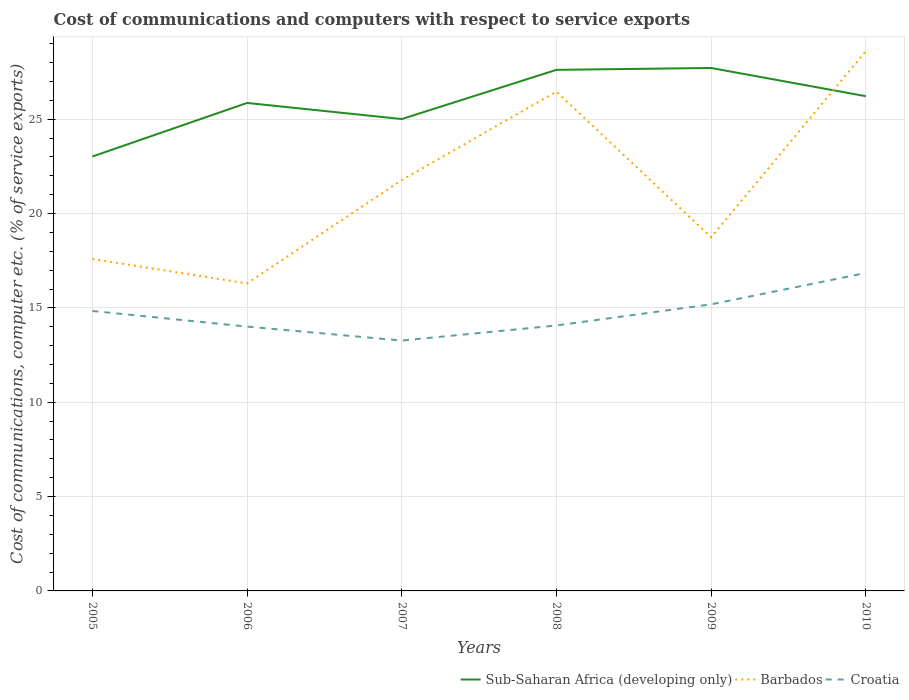Is the number of lines equal to the number of legend labels?
Provide a short and direct response. Yes. Across all years, what is the maximum cost of communications and computers in Sub-Saharan Africa (developing only)?
Make the answer very short. 23.02. What is the total cost of communications and computers in Croatia in the graph?
Your response must be concise. 0.83. What is the difference between the highest and the second highest cost of communications and computers in Barbados?
Your answer should be compact. 12.31. What is the difference between the highest and the lowest cost of communications and computers in Barbados?
Provide a short and direct response. 3. Is the cost of communications and computers in Croatia strictly greater than the cost of communications and computers in Sub-Saharan Africa (developing only) over the years?
Your answer should be compact. Yes. What is the difference between two consecutive major ticks on the Y-axis?
Ensure brevity in your answer.  5. Does the graph contain grids?
Make the answer very short. Yes. Where does the legend appear in the graph?
Make the answer very short. Bottom right. How many legend labels are there?
Give a very brief answer. 3. How are the legend labels stacked?
Your response must be concise. Horizontal. What is the title of the graph?
Offer a very short reply. Cost of communications and computers with respect to service exports. Does "San Marino" appear as one of the legend labels in the graph?
Offer a very short reply. No. What is the label or title of the Y-axis?
Keep it short and to the point. Cost of communications, computer etc. (% of service exports). What is the Cost of communications, computer etc. (% of service exports) of Sub-Saharan Africa (developing only) in 2005?
Ensure brevity in your answer.  23.02. What is the Cost of communications, computer etc. (% of service exports) of Barbados in 2005?
Ensure brevity in your answer.  17.59. What is the Cost of communications, computer etc. (% of service exports) of Croatia in 2005?
Your answer should be very brief. 14.84. What is the Cost of communications, computer etc. (% of service exports) of Sub-Saharan Africa (developing only) in 2006?
Give a very brief answer. 25.86. What is the Cost of communications, computer etc. (% of service exports) of Barbados in 2006?
Your response must be concise. 16.3. What is the Cost of communications, computer etc. (% of service exports) of Croatia in 2006?
Your answer should be compact. 14.01. What is the Cost of communications, computer etc. (% of service exports) in Sub-Saharan Africa (developing only) in 2007?
Your response must be concise. 25.01. What is the Cost of communications, computer etc. (% of service exports) of Barbados in 2007?
Make the answer very short. 21.77. What is the Cost of communications, computer etc. (% of service exports) in Croatia in 2007?
Your response must be concise. 13.27. What is the Cost of communications, computer etc. (% of service exports) in Sub-Saharan Africa (developing only) in 2008?
Your answer should be compact. 27.62. What is the Cost of communications, computer etc. (% of service exports) in Barbados in 2008?
Make the answer very short. 26.46. What is the Cost of communications, computer etc. (% of service exports) of Croatia in 2008?
Your answer should be very brief. 14.07. What is the Cost of communications, computer etc. (% of service exports) in Sub-Saharan Africa (developing only) in 2009?
Offer a very short reply. 27.71. What is the Cost of communications, computer etc. (% of service exports) of Barbados in 2009?
Provide a short and direct response. 18.74. What is the Cost of communications, computer etc. (% of service exports) of Croatia in 2009?
Offer a terse response. 15.19. What is the Cost of communications, computer etc. (% of service exports) of Sub-Saharan Africa (developing only) in 2010?
Your answer should be very brief. 26.22. What is the Cost of communications, computer etc. (% of service exports) of Barbados in 2010?
Offer a terse response. 28.61. What is the Cost of communications, computer etc. (% of service exports) of Croatia in 2010?
Provide a short and direct response. 16.85. Across all years, what is the maximum Cost of communications, computer etc. (% of service exports) of Sub-Saharan Africa (developing only)?
Offer a terse response. 27.71. Across all years, what is the maximum Cost of communications, computer etc. (% of service exports) of Barbados?
Provide a short and direct response. 28.61. Across all years, what is the maximum Cost of communications, computer etc. (% of service exports) of Croatia?
Offer a terse response. 16.85. Across all years, what is the minimum Cost of communications, computer etc. (% of service exports) of Sub-Saharan Africa (developing only)?
Make the answer very short. 23.02. Across all years, what is the minimum Cost of communications, computer etc. (% of service exports) in Barbados?
Give a very brief answer. 16.3. Across all years, what is the minimum Cost of communications, computer etc. (% of service exports) of Croatia?
Your response must be concise. 13.27. What is the total Cost of communications, computer etc. (% of service exports) in Sub-Saharan Africa (developing only) in the graph?
Make the answer very short. 155.44. What is the total Cost of communications, computer etc. (% of service exports) of Barbados in the graph?
Your response must be concise. 129.48. What is the total Cost of communications, computer etc. (% of service exports) of Croatia in the graph?
Ensure brevity in your answer.  88.22. What is the difference between the Cost of communications, computer etc. (% of service exports) of Sub-Saharan Africa (developing only) in 2005 and that in 2006?
Ensure brevity in your answer.  -2.84. What is the difference between the Cost of communications, computer etc. (% of service exports) in Barbados in 2005 and that in 2006?
Make the answer very short. 1.29. What is the difference between the Cost of communications, computer etc. (% of service exports) of Croatia in 2005 and that in 2006?
Make the answer very short. 0.83. What is the difference between the Cost of communications, computer etc. (% of service exports) of Sub-Saharan Africa (developing only) in 2005 and that in 2007?
Offer a terse response. -1.99. What is the difference between the Cost of communications, computer etc. (% of service exports) in Barbados in 2005 and that in 2007?
Ensure brevity in your answer.  -4.18. What is the difference between the Cost of communications, computer etc. (% of service exports) of Croatia in 2005 and that in 2007?
Keep it short and to the point. 1.57. What is the difference between the Cost of communications, computer etc. (% of service exports) of Sub-Saharan Africa (developing only) in 2005 and that in 2008?
Offer a very short reply. -4.59. What is the difference between the Cost of communications, computer etc. (% of service exports) in Barbados in 2005 and that in 2008?
Keep it short and to the point. -8.87. What is the difference between the Cost of communications, computer etc. (% of service exports) in Croatia in 2005 and that in 2008?
Your response must be concise. 0.77. What is the difference between the Cost of communications, computer etc. (% of service exports) in Sub-Saharan Africa (developing only) in 2005 and that in 2009?
Your response must be concise. -4.69. What is the difference between the Cost of communications, computer etc. (% of service exports) of Barbados in 2005 and that in 2009?
Offer a very short reply. -1.15. What is the difference between the Cost of communications, computer etc. (% of service exports) of Croatia in 2005 and that in 2009?
Your answer should be very brief. -0.35. What is the difference between the Cost of communications, computer etc. (% of service exports) in Sub-Saharan Africa (developing only) in 2005 and that in 2010?
Offer a very short reply. -3.2. What is the difference between the Cost of communications, computer etc. (% of service exports) in Barbados in 2005 and that in 2010?
Keep it short and to the point. -11.02. What is the difference between the Cost of communications, computer etc. (% of service exports) of Croatia in 2005 and that in 2010?
Offer a very short reply. -2.02. What is the difference between the Cost of communications, computer etc. (% of service exports) in Sub-Saharan Africa (developing only) in 2006 and that in 2007?
Your response must be concise. 0.85. What is the difference between the Cost of communications, computer etc. (% of service exports) of Barbados in 2006 and that in 2007?
Offer a very short reply. -5.48. What is the difference between the Cost of communications, computer etc. (% of service exports) in Croatia in 2006 and that in 2007?
Ensure brevity in your answer.  0.74. What is the difference between the Cost of communications, computer etc. (% of service exports) of Sub-Saharan Africa (developing only) in 2006 and that in 2008?
Ensure brevity in your answer.  -1.75. What is the difference between the Cost of communications, computer etc. (% of service exports) of Barbados in 2006 and that in 2008?
Ensure brevity in your answer.  -10.16. What is the difference between the Cost of communications, computer etc. (% of service exports) of Croatia in 2006 and that in 2008?
Offer a terse response. -0.06. What is the difference between the Cost of communications, computer etc. (% of service exports) of Sub-Saharan Africa (developing only) in 2006 and that in 2009?
Your response must be concise. -1.85. What is the difference between the Cost of communications, computer etc. (% of service exports) in Barbados in 2006 and that in 2009?
Provide a succinct answer. -2.44. What is the difference between the Cost of communications, computer etc. (% of service exports) in Croatia in 2006 and that in 2009?
Offer a terse response. -1.18. What is the difference between the Cost of communications, computer etc. (% of service exports) in Sub-Saharan Africa (developing only) in 2006 and that in 2010?
Make the answer very short. -0.36. What is the difference between the Cost of communications, computer etc. (% of service exports) of Barbados in 2006 and that in 2010?
Provide a short and direct response. -12.31. What is the difference between the Cost of communications, computer etc. (% of service exports) in Croatia in 2006 and that in 2010?
Make the answer very short. -2.84. What is the difference between the Cost of communications, computer etc. (% of service exports) in Sub-Saharan Africa (developing only) in 2007 and that in 2008?
Provide a succinct answer. -2.61. What is the difference between the Cost of communications, computer etc. (% of service exports) in Barbados in 2007 and that in 2008?
Give a very brief answer. -4.69. What is the difference between the Cost of communications, computer etc. (% of service exports) in Croatia in 2007 and that in 2008?
Your answer should be very brief. -0.8. What is the difference between the Cost of communications, computer etc. (% of service exports) of Sub-Saharan Africa (developing only) in 2007 and that in 2009?
Offer a very short reply. -2.71. What is the difference between the Cost of communications, computer etc. (% of service exports) in Barbados in 2007 and that in 2009?
Your answer should be compact. 3.03. What is the difference between the Cost of communications, computer etc. (% of service exports) of Croatia in 2007 and that in 2009?
Your answer should be very brief. -1.92. What is the difference between the Cost of communications, computer etc. (% of service exports) in Sub-Saharan Africa (developing only) in 2007 and that in 2010?
Keep it short and to the point. -1.21. What is the difference between the Cost of communications, computer etc. (% of service exports) in Barbados in 2007 and that in 2010?
Provide a succinct answer. -6.84. What is the difference between the Cost of communications, computer etc. (% of service exports) of Croatia in 2007 and that in 2010?
Offer a terse response. -3.58. What is the difference between the Cost of communications, computer etc. (% of service exports) of Sub-Saharan Africa (developing only) in 2008 and that in 2009?
Provide a short and direct response. -0.1. What is the difference between the Cost of communications, computer etc. (% of service exports) in Barbados in 2008 and that in 2009?
Your response must be concise. 7.72. What is the difference between the Cost of communications, computer etc. (% of service exports) of Croatia in 2008 and that in 2009?
Give a very brief answer. -1.12. What is the difference between the Cost of communications, computer etc. (% of service exports) of Sub-Saharan Africa (developing only) in 2008 and that in 2010?
Provide a short and direct response. 1.4. What is the difference between the Cost of communications, computer etc. (% of service exports) of Barbados in 2008 and that in 2010?
Make the answer very short. -2.15. What is the difference between the Cost of communications, computer etc. (% of service exports) in Croatia in 2008 and that in 2010?
Give a very brief answer. -2.78. What is the difference between the Cost of communications, computer etc. (% of service exports) in Sub-Saharan Africa (developing only) in 2009 and that in 2010?
Give a very brief answer. 1.5. What is the difference between the Cost of communications, computer etc. (% of service exports) of Barbados in 2009 and that in 2010?
Your response must be concise. -9.87. What is the difference between the Cost of communications, computer etc. (% of service exports) in Croatia in 2009 and that in 2010?
Ensure brevity in your answer.  -1.66. What is the difference between the Cost of communications, computer etc. (% of service exports) in Sub-Saharan Africa (developing only) in 2005 and the Cost of communications, computer etc. (% of service exports) in Barbados in 2006?
Provide a short and direct response. 6.73. What is the difference between the Cost of communications, computer etc. (% of service exports) of Sub-Saharan Africa (developing only) in 2005 and the Cost of communications, computer etc. (% of service exports) of Croatia in 2006?
Provide a short and direct response. 9.01. What is the difference between the Cost of communications, computer etc. (% of service exports) of Barbados in 2005 and the Cost of communications, computer etc. (% of service exports) of Croatia in 2006?
Your answer should be compact. 3.58. What is the difference between the Cost of communications, computer etc. (% of service exports) of Sub-Saharan Africa (developing only) in 2005 and the Cost of communications, computer etc. (% of service exports) of Barbados in 2007?
Give a very brief answer. 1.25. What is the difference between the Cost of communications, computer etc. (% of service exports) in Sub-Saharan Africa (developing only) in 2005 and the Cost of communications, computer etc. (% of service exports) in Croatia in 2007?
Provide a short and direct response. 9.75. What is the difference between the Cost of communications, computer etc. (% of service exports) in Barbados in 2005 and the Cost of communications, computer etc. (% of service exports) in Croatia in 2007?
Give a very brief answer. 4.32. What is the difference between the Cost of communications, computer etc. (% of service exports) of Sub-Saharan Africa (developing only) in 2005 and the Cost of communications, computer etc. (% of service exports) of Barbados in 2008?
Offer a very short reply. -3.44. What is the difference between the Cost of communications, computer etc. (% of service exports) in Sub-Saharan Africa (developing only) in 2005 and the Cost of communications, computer etc. (% of service exports) in Croatia in 2008?
Ensure brevity in your answer.  8.96. What is the difference between the Cost of communications, computer etc. (% of service exports) in Barbados in 2005 and the Cost of communications, computer etc. (% of service exports) in Croatia in 2008?
Keep it short and to the point. 3.52. What is the difference between the Cost of communications, computer etc. (% of service exports) in Sub-Saharan Africa (developing only) in 2005 and the Cost of communications, computer etc. (% of service exports) in Barbados in 2009?
Make the answer very short. 4.28. What is the difference between the Cost of communications, computer etc. (% of service exports) in Sub-Saharan Africa (developing only) in 2005 and the Cost of communications, computer etc. (% of service exports) in Croatia in 2009?
Your answer should be compact. 7.83. What is the difference between the Cost of communications, computer etc. (% of service exports) of Barbados in 2005 and the Cost of communications, computer etc. (% of service exports) of Croatia in 2009?
Your response must be concise. 2.4. What is the difference between the Cost of communications, computer etc. (% of service exports) in Sub-Saharan Africa (developing only) in 2005 and the Cost of communications, computer etc. (% of service exports) in Barbados in 2010?
Ensure brevity in your answer.  -5.59. What is the difference between the Cost of communications, computer etc. (% of service exports) of Sub-Saharan Africa (developing only) in 2005 and the Cost of communications, computer etc. (% of service exports) of Croatia in 2010?
Provide a succinct answer. 6.17. What is the difference between the Cost of communications, computer etc. (% of service exports) of Barbados in 2005 and the Cost of communications, computer etc. (% of service exports) of Croatia in 2010?
Make the answer very short. 0.74. What is the difference between the Cost of communications, computer etc. (% of service exports) of Sub-Saharan Africa (developing only) in 2006 and the Cost of communications, computer etc. (% of service exports) of Barbados in 2007?
Provide a succinct answer. 4.09. What is the difference between the Cost of communications, computer etc. (% of service exports) of Sub-Saharan Africa (developing only) in 2006 and the Cost of communications, computer etc. (% of service exports) of Croatia in 2007?
Keep it short and to the point. 12.59. What is the difference between the Cost of communications, computer etc. (% of service exports) in Barbados in 2006 and the Cost of communications, computer etc. (% of service exports) in Croatia in 2007?
Provide a succinct answer. 3.03. What is the difference between the Cost of communications, computer etc. (% of service exports) in Sub-Saharan Africa (developing only) in 2006 and the Cost of communications, computer etc. (% of service exports) in Barbados in 2008?
Provide a short and direct response. -0.6. What is the difference between the Cost of communications, computer etc. (% of service exports) of Sub-Saharan Africa (developing only) in 2006 and the Cost of communications, computer etc. (% of service exports) of Croatia in 2008?
Your answer should be very brief. 11.79. What is the difference between the Cost of communications, computer etc. (% of service exports) of Barbados in 2006 and the Cost of communications, computer etc. (% of service exports) of Croatia in 2008?
Provide a short and direct response. 2.23. What is the difference between the Cost of communications, computer etc. (% of service exports) in Sub-Saharan Africa (developing only) in 2006 and the Cost of communications, computer etc. (% of service exports) in Barbados in 2009?
Keep it short and to the point. 7.12. What is the difference between the Cost of communications, computer etc. (% of service exports) in Sub-Saharan Africa (developing only) in 2006 and the Cost of communications, computer etc. (% of service exports) in Croatia in 2009?
Your answer should be very brief. 10.67. What is the difference between the Cost of communications, computer etc. (% of service exports) in Barbados in 2006 and the Cost of communications, computer etc. (% of service exports) in Croatia in 2009?
Offer a very short reply. 1.11. What is the difference between the Cost of communications, computer etc. (% of service exports) of Sub-Saharan Africa (developing only) in 2006 and the Cost of communications, computer etc. (% of service exports) of Barbados in 2010?
Offer a terse response. -2.75. What is the difference between the Cost of communications, computer etc. (% of service exports) of Sub-Saharan Africa (developing only) in 2006 and the Cost of communications, computer etc. (% of service exports) of Croatia in 2010?
Offer a terse response. 9.01. What is the difference between the Cost of communications, computer etc. (% of service exports) of Barbados in 2006 and the Cost of communications, computer etc. (% of service exports) of Croatia in 2010?
Ensure brevity in your answer.  -0.55. What is the difference between the Cost of communications, computer etc. (% of service exports) in Sub-Saharan Africa (developing only) in 2007 and the Cost of communications, computer etc. (% of service exports) in Barbados in 2008?
Offer a terse response. -1.45. What is the difference between the Cost of communications, computer etc. (% of service exports) in Sub-Saharan Africa (developing only) in 2007 and the Cost of communications, computer etc. (% of service exports) in Croatia in 2008?
Offer a terse response. 10.94. What is the difference between the Cost of communications, computer etc. (% of service exports) of Barbados in 2007 and the Cost of communications, computer etc. (% of service exports) of Croatia in 2008?
Give a very brief answer. 7.71. What is the difference between the Cost of communications, computer etc. (% of service exports) in Sub-Saharan Africa (developing only) in 2007 and the Cost of communications, computer etc. (% of service exports) in Barbados in 2009?
Keep it short and to the point. 6.27. What is the difference between the Cost of communications, computer etc. (% of service exports) in Sub-Saharan Africa (developing only) in 2007 and the Cost of communications, computer etc. (% of service exports) in Croatia in 2009?
Provide a short and direct response. 9.82. What is the difference between the Cost of communications, computer etc. (% of service exports) of Barbados in 2007 and the Cost of communications, computer etc. (% of service exports) of Croatia in 2009?
Provide a short and direct response. 6.59. What is the difference between the Cost of communications, computer etc. (% of service exports) of Sub-Saharan Africa (developing only) in 2007 and the Cost of communications, computer etc. (% of service exports) of Barbados in 2010?
Keep it short and to the point. -3.6. What is the difference between the Cost of communications, computer etc. (% of service exports) of Sub-Saharan Africa (developing only) in 2007 and the Cost of communications, computer etc. (% of service exports) of Croatia in 2010?
Provide a succinct answer. 8.16. What is the difference between the Cost of communications, computer etc. (% of service exports) in Barbados in 2007 and the Cost of communications, computer etc. (% of service exports) in Croatia in 2010?
Offer a very short reply. 4.92. What is the difference between the Cost of communications, computer etc. (% of service exports) of Sub-Saharan Africa (developing only) in 2008 and the Cost of communications, computer etc. (% of service exports) of Barbados in 2009?
Keep it short and to the point. 8.88. What is the difference between the Cost of communications, computer etc. (% of service exports) in Sub-Saharan Africa (developing only) in 2008 and the Cost of communications, computer etc. (% of service exports) in Croatia in 2009?
Offer a terse response. 12.43. What is the difference between the Cost of communications, computer etc. (% of service exports) of Barbados in 2008 and the Cost of communications, computer etc. (% of service exports) of Croatia in 2009?
Your response must be concise. 11.27. What is the difference between the Cost of communications, computer etc. (% of service exports) of Sub-Saharan Africa (developing only) in 2008 and the Cost of communications, computer etc. (% of service exports) of Barbados in 2010?
Provide a succinct answer. -1. What is the difference between the Cost of communications, computer etc. (% of service exports) in Sub-Saharan Africa (developing only) in 2008 and the Cost of communications, computer etc. (% of service exports) in Croatia in 2010?
Your answer should be compact. 10.76. What is the difference between the Cost of communications, computer etc. (% of service exports) of Barbados in 2008 and the Cost of communications, computer etc. (% of service exports) of Croatia in 2010?
Your answer should be compact. 9.61. What is the difference between the Cost of communications, computer etc. (% of service exports) in Sub-Saharan Africa (developing only) in 2009 and the Cost of communications, computer etc. (% of service exports) in Barbados in 2010?
Your response must be concise. -0.9. What is the difference between the Cost of communications, computer etc. (% of service exports) of Sub-Saharan Africa (developing only) in 2009 and the Cost of communications, computer etc. (% of service exports) of Croatia in 2010?
Your answer should be compact. 10.86. What is the difference between the Cost of communications, computer etc. (% of service exports) in Barbados in 2009 and the Cost of communications, computer etc. (% of service exports) in Croatia in 2010?
Make the answer very short. 1.89. What is the average Cost of communications, computer etc. (% of service exports) of Sub-Saharan Africa (developing only) per year?
Your answer should be compact. 25.91. What is the average Cost of communications, computer etc. (% of service exports) of Barbados per year?
Offer a very short reply. 21.58. What is the average Cost of communications, computer etc. (% of service exports) in Croatia per year?
Keep it short and to the point. 14.7. In the year 2005, what is the difference between the Cost of communications, computer etc. (% of service exports) of Sub-Saharan Africa (developing only) and Cost of communications, computer etc. (% of service exports) of Barbados?
Ensure brevity in your answer.  5.43. In the year 2005, what is the difference between the Cost of communications, computer etc. (% of service exports) in Sub-Saharan Africa (developing only) and Cost of communications, computer etc. (% of service exports) in Croatia?
Your answer should be compact. 8.19. In the year 2005, what is the difference between the Cost of communications, computer etc. (% of service exports) of Barbados and Cost of communications, computer etc. (% of service exports) of Croatia?
Offer a terse response. 2.75. In the year 2006, what is the difference between the Cost of communications, computer etc. (% of service exports) of Sub-Saharan Africa (developing only) and Cost of communications, computer etc. (% of service exports) of Barbados?
Provide a succinct answer. 9.56. In the year 2006, what is the difference between the Cost of communications, computer etc. (% of service exports) of Sub-Saharan Africa (developing only) and Cost of communications, computer etc. (% of service exports) of Croatia?
Offer a very short reply. 11.85. In the year 2006, what is the difference between the Cost of communications, computer etc. (% of service exports) in Barbados and Cost of communications, computer etc. (% of service exports) in Croatia?
Give a very brief answer. 2.29. In the year 2007, what is the difference between the Cost of communications, computer etc. (% of service exports) in Sub-Saharan Africa (developing only) and Cost of communications, computer etc. (% of service exports) in Barbados?
Keep it short and to the point. 3.23. In the year 2007, what is the difference between the Cost of communications, computer etc. (% of service exports) of Sub-Saharan Africa (developing only) and Cost of communications, computer etc. (% of service exports) of Croatia?
Offer a terse response. 11.74. In the year 2007, what is the difference between the Cost of communications, computer etc. (% of service exports) in Barbados and Cost of communications, computer etc. (% of service exports) in Croatia?
Give a very brief answer. 8.51. In the year 2008, what is the difference between the Cost of communications, computer etc. (% of service exports) in Sub-Saharan Africa (developing only) and Cost of communications, computer etc. (% of service exports) in Barbados?
Your response must be concise. 1.15. In the year 2008, what is the difference between the Cost of communications, computer etc. (% of service exports) in Sub-Saharan Africa (developing only) and Cost of communications, computer etc. (% of service exports) in Croatia?
Offer a terse response. 13.55. In the year 2008, what is the difference between the Cost of communications, computer etc. (% of service exports) in Barbados and Cost of communications, computer etc. (% of service exports) in Croatia?
Your response must be concise. 12.39. In the year 2009, what is the difference between the Cost of communications, computer etc. (% of service exports) of Sub-Saharan Africa (developing only) and Cost of communications, computer etc. (% of service exports) of Barbados?
Your answer should be very brief. 8.97. In the year 2009, what is the difference between the Cost of communications, computer etc. (% of service exports) of Sub-Saharan Africa (developing only) and Cost of communications, computer etc. (% of service exports) of Croatia?
Provide a succinct answer. 12.53. In the year 2009, what is the difference between the Cost of communications, computer etc. (% of service exports) of Barbados and Cost of communications, computer etc. (% of service exports) of Croatia?
Keep it short and to the point. 3.55. In the year 2010, what is the difference between the Cost of communications, computer etc. (% of service exports) in Sub-Saharan Africa (developing only) and Cost of communications, computer etc. (% of service exports) in Barbados?
Make the answer very short. -2.39. In the year 2010, what is the difference between the Cost of communications, computer etc. (% of service exports) of Sub-Saharan Africa (developing only) and Cost of communications, computer etc. (% of service exports) of Croatia?
Give a very brief answer. 9.37. In the year 2010, what is the difference between the Cost of communications, computer etc. (% of service exports) in Barbados and Cost of communications, computer etc. (% of service exports) in Croatia?
Offer a very short reply. 11.76. What is the ratio of the Cost of communications, computer etc. (% of service exports) of Sub-Saharan Africa (developing only) in 2005 to that in 2006?
Keep it short and to the point. 0.89. What is the ratio of the Cost of communications, computer etc. (% of service exports) of Barbados in 2005 to that in 2006?
Give a very brief answer. 1.08. What is the ratio of the Cost of communications, computer etc. (% of service exports) in Croatia in 2005 to that in 2006?
Offer a very short reply. 1.06. What is the ratio of the Cost of communications, computer etc. (% of service exports) of Sub-Saharan Africa (developing only) in 2005 to that in 2007?
Offer a very short reply. 0.92. What is the ratio of the Cost of communications, computer etc. (% of service exports) of Barbados in 2005 to that in 2007?
Make the answer very short. 0.81. What is the ratio of the Cost of communications, computer etc. (% of service exports) in Croatia in 2005 to that in 2007?
Your answer should be very brief. 1.12. What is the ratio of the Cost of communications, computer etc. (% of service exports) in Sub-Saharan Africa (developing only) in 2005 to that in 2008?
Offer a very short reply. 0.83. What is the ratio of the Cost of communications, computer etc. (% of service exports) of Barbados in 2005 to that in 2008?
Provide a short and direct response. 0.66. What is the ratio of the Cost of communications, computer etc. (% of service exports) of Croatia in 2005 to that in 2008?
Your response must be concise. 1.05. What is the ratio of the Cost of communications, computer etc. (% of service exports) in Sub-Saharan Africa (developing only) in 2005 to that in 2009?
Keep it short and to the point. 0.83. What is the ratio of the Cost of communications, computer etc. (% of service exports) of Barbados in 2005 to that in 2009?
Provide a short and direct response. 0.94. What is the ratio of the Cost of communications, computer etc. (% of service exports) in Croatia in 2005 to that in 2009?
Give a very brief answer. 0.98. What is the ratio of the Cost of communications, computer etc. (% of service exports) of Sub-Saharan Africa (developing only) in 2005 to that in 2010?
Provide a short and direct response. 0.88. What is the ratio of the Cost of communications, computer etc. (% of service exports) of Barbados in 2005 to that in 2010?
Your answer should be compact. 0.61. What is the ratio of the Cost of communications, computer etc. (% of service exports) in Croatia in 2005 to that in 2010?
Offer a terse response. 0.88. What is the ratio of the Cost of communications, computer etc. (% of service exports) in Sub-Saharan Africa (developing only) in 2006 to that in 2007?
Provide a short and direct response. 1.03. What is the ratio of the Cost of communications, computer etc. (% of service exports) in Barbados in 2006 to that in 2007?
Offer a very short reply. 0.75. What is the ratio of the Cost of communications, computer etc. (% of service exports) in Croatia in 2006 to that in 2007?
Ensure brevity in your answer.  1.06. What is the ratio of the Cost of communications, computer etc. (% of service exports) in Sub-Saharan Africa (developing only) in 2006 to that in 2008?
Keep it short and to the point. 0.94. What is the ratio of the Cost of communications, computer etc. (% of service exports) in Barbados in 2006 to that in 2008?
Provide a short and direct response. 0.62. What is the ratio of the Cost of communications, computer etc. (% of service exports) of Croatia in 2006 to that in 2008?
Keep it short and to the point. 1. What is the ratio of the Cost of communications, computer etc. (% of service exports) in Sub-Saharan Africa (developing only) in 2006 to that in 2009?
Offer a terse response. 0.93. What is the ratio of the Cost of communications, computer etc. (% of service exports) in Barbados in 2006 to that in 2009?
Provide a short and direct response. 0.87. What is the ratio of the Cost of communications, computer etc. (% of service exports) of Croatia in 2006 to that in 2009?
Offer a terse response. 0.92. What is the ratio of the Cost of communications, computer etc. (% of service exports) in Sub-Saharan Africa (developing only) in 2006 to that in 2010?
Provide a short and direct response. 0.99. What is the ratio of the Cost of communications, computer etc. (% of service exports) in Barbados in 2006 to that in 2010?
Give a very brief answer. 0.57. What is the ratio of the Cost of communications, computer etc. (% of service exports) in Croatia in 2006 to that in 2010?
Ensure brevity in your answer.  0.83. What is the ratio of the Cost of communications, computer etc. (% of service exports) of Sub-Saharan Africa (developing only) in 2007 to that in 2008?
Give a very brief answer. 0.91. What is the ratio of the Cost of communications, computer etc. (% of service exports) of Barbados in 2007 to that in 2008?
Provide a short and direct response. 0.82. What is the ratio of the Cost of communications, computer etc. (% of service exports) in Croatia in 2007 to that in 2008?
Offer a very short reply. 0.94. What is the ratio of the Cost of communications, computer etc. (% of service exports) of Sub-Saharan Africa (developing only) in 2007 to that in 2009?
Your answer should be compact. 0.9. What is the ratio of the Cost of communications, computer etc. (% of service exports) in Barbados in 2007 to that in 2009?
Your response must be concise. 1.16. What is the ratio of the Cost of communications, computer etc. (% of service exports) of Croatia in 2007 to that in 2009?
Make the answer very short. 0.87. What is the ratio of the Cost of communications, computer etc. (% of service exports) in Sub-Saharan Africa (developing only) in 2007 to that in 2010?
Provide a short and direct response. 0.95. What is the ratio of the Cost of communications, computer etc. (% of service exports) in Barbados in 2007 to that in 2010?
Provide a succinct answer. 0.76. What is the ratio of the Cost of communications, computer etc. (% of service exports) in Croatia in 2007 to that in 2010?
Your response must be concise. 0.79. What is the ratio of the Cost of communications, computer etc. (% of service exports) in Barbados in 2008 to that in 2009?
Ensure brevity in your answer.  1.41. What is the ratio of the Cost of communications, computer etc. (% of service exports) of Croatia in 2008 to that in 2009?
Keep it short and to the point. 0.93. What is the ratio of the Cost of communications, computer etc. (% of service exports) in Sub-Saharan Africa (developing only) in 2008 to that in 2010?
Your response must be concise. 1.05. What is the ratio of the Cost of communications, computer etc. (% of service exports) of Barbados in 2008 to that in 2010?
Provide a short and direct response. 0.92. What is the ratio of the Cost of communications, computer etc. (% of service exports) in Croatia in 2008 to that in 2010?
Give a very brief answer. 0.83. What is the ratio of the Cost of communications, computer etc. (% of service exports) of Sub-Saharan Africa (developing only) in 2009 to that in 2010?
Keep it short and to the point. 1.06. What is the ratio of the Cost of communications, computer etc. (% of service exports) of Barbados in 2009 to that in 2010?
Your response must be concise. 0.66. What is the ratio of the Cost of communications, computer etc. (% of service exports) of Croatia in 2009 to that in 2010?
Give a very brief answer. 0.9. What is the difference between the highest and the second highest Cost of communications, computer etc. (% of service exports) of Sub-Saharan Africa (developing only)?
Provide a succinct answer. 0.1. What is the difference between the highest and the second highest Cost of communications, computer etc. (% of service exports) of Barbados?
Your response must be concise. 2.15. What is the difference between the highest and the second highest Cost of communications, computer etc. (% of service exports) in Croatia?
Provide a short and direct response. 1.66. What is the difference between the highest and the lowest Cost of communications, computer etc. (% of service exports) of Sub-Saharan Africa (developing only)?
Your response must be concise. 4.69. What is the difference between the highest and the lowest Cost of communications, computer etc. (% of service exports) of Barbados?
Your answer should be very brief. 12.31. What is the difference between the highest and the lowest Cost of communications, computer etc. (% of service exports) of Croatia?
Provide a succinct answer. 3.58. 